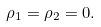Convert formula to latex. <formula><loc_0><loc_0><loc_500><loc_500>\rho _ { 1 } = \rho _ { 2 } = 0 .</formula> 